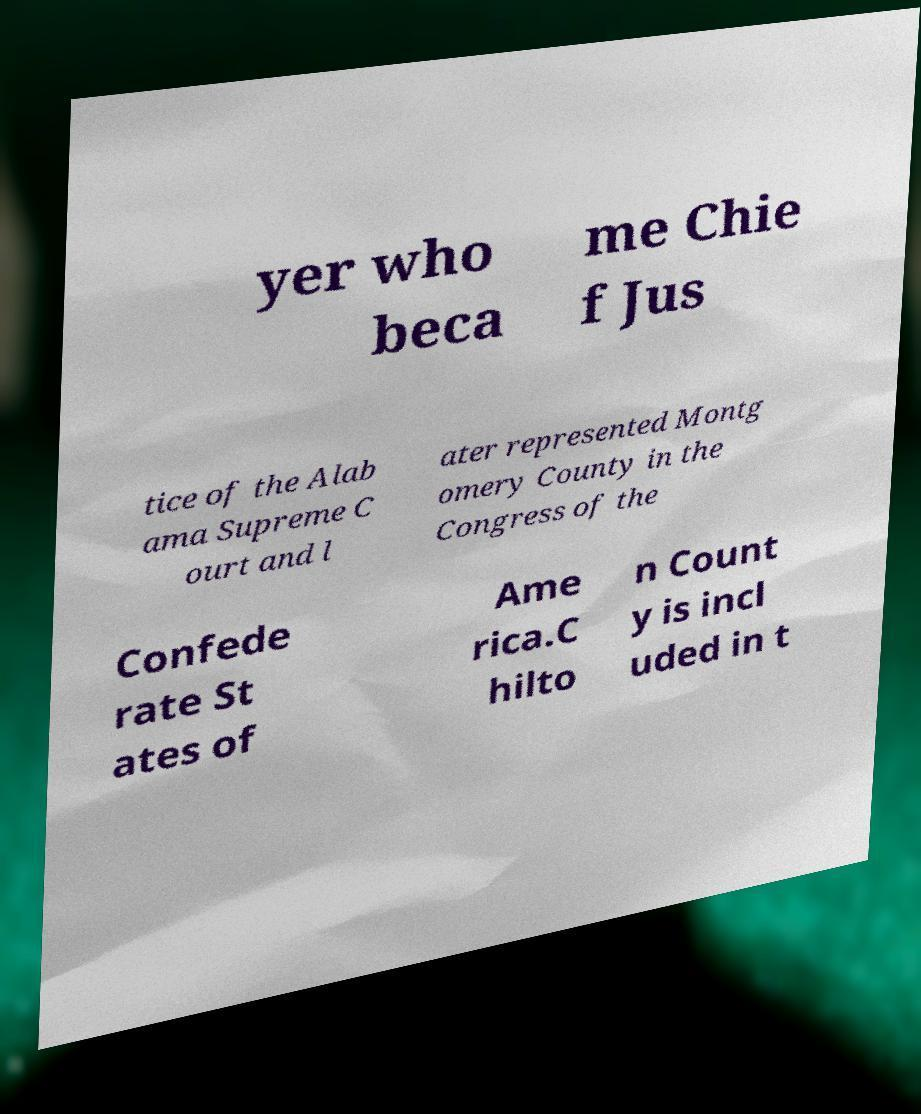Can you read and provide the text displayed in the image?This photo seems to have some interesting text. Can you extract and type it out for me? yer who beca me Chie f Jus tice of the Alab ama Supreme C ourt and l ater represented Montg omery County in the Congress of the Confede rate St ates of Ame rica.C hilto n Count y is incl uded in t 